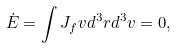Convert formula to latex. <formula><loc_0><loc_0><loc_500><loc_500>\dot { E } = \int { J } _ { f } { v } d ^ { 3 } { r } d ^ { 3 } { v } = 0 ,</formula> 